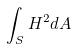Convert formula to latex. <formula><loc_0><loc_0><loc_500><loc_500>\int _ { S } H ^ { 2 } d A</formula> 